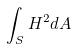Convert formula to latex. <formula><loc_0><loc_0><loc_500><loc_500>\int _ { S } H ^ { 2 } d A</formula> 